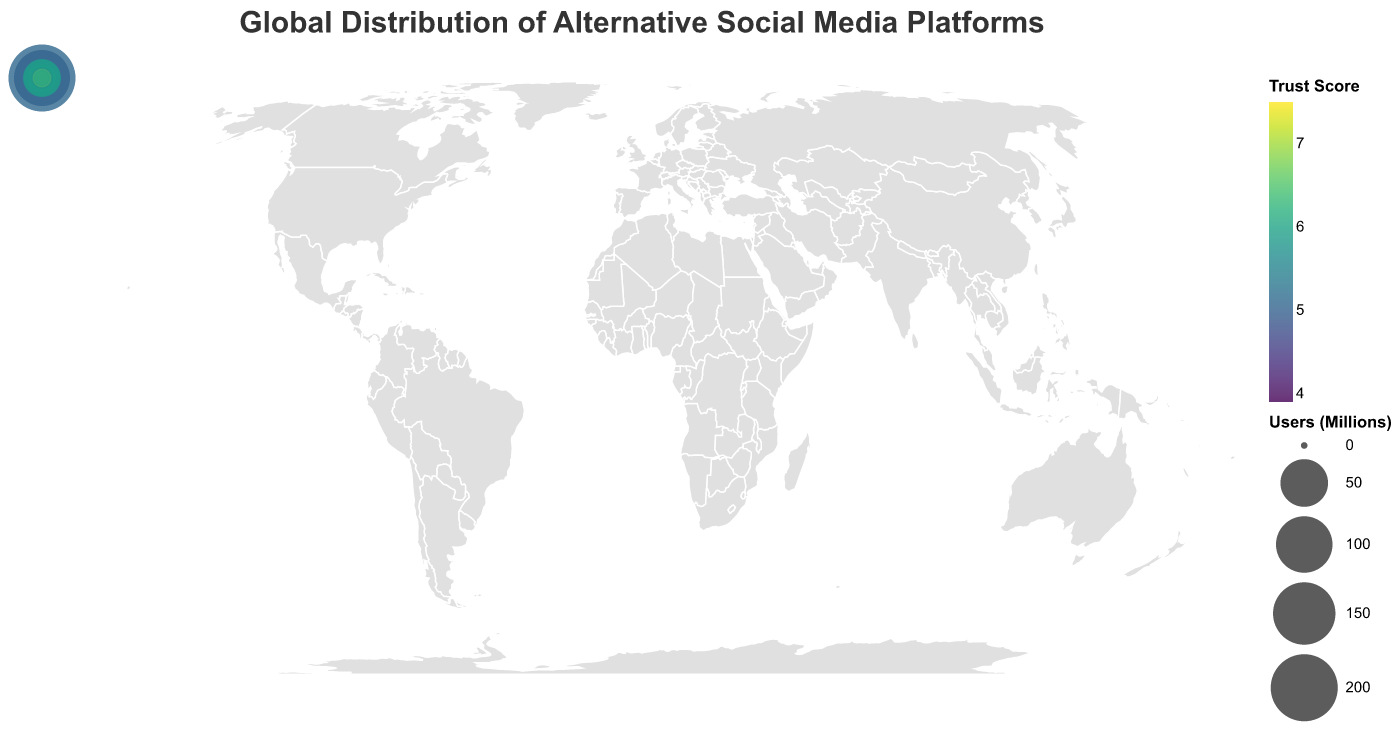What is the title of the figure? The title is written at the top of the figure. It reads "Global Distribution of Alternative Social Media Platforms"
Answer: Global Distribution of Alternative Social Media Platforms Which country has the highest number of users for its alternative social media platform, and what is the user count? By examining the sizes of the circles, we can see that China has the highest user count. The tooltip confirms this by displaying 200.0 million users for Douban in China.
Answer: China, 200 million What is the trust score of the platform with the highest number of users? The platform with the highest number of users is Douban in China. Looking at the tooltip, Douban has a trust score of 5.1.
Answer: 5.1 Which platform has the highest trust score, and in which country is it located? The tooltip data for Framasoft in France indicates a trust score of 7.5, which is the highest trust score among the platforms.
Answer: Framasoft, France How many countries have platforms with a trust score higher than 6.5? By hovering over and checking the tooltips of each country's platform, we find that the countries with trust scores higher than 6.5 include the United States (Mastodon, 7.2), Germany (Diaspora, 6.9), France (Framasoft, 7.5), Spain (Pleroma, 6.7), Netherlands (Movim, 6.4), and Sweden (Hubzilla, 6.8). Counting these gives us 6 countries.
Answer: 6 Which country has the lowest trust score for its alternative social media platform, and what is the trust score? The tooltip data for Gab in the United Kingdom shows a trust score of 3.9, which is the lowest.
Answer: United Kingdom, 3.9 Compare the user base of Mastodon in the United States and Koo in India. Which has more users, and by how much? Mastodon has 4.5 million users, and Koo has 20.0 million users. Subtracting 4.5 from 20.0 gives us 15.5 million.
Answer: Koo, by 15.5 million What is the average trust score of all the platforms? To find the average trust score, sum all the trust scores and divide by the number of data points. The trust scores are 7.2, 6.9, 6.5, 6.3, 4.8, 5.1, 5.7, 3.9, 4.2, 5.8, 7.5, 6.7, 6.4, 6.8, and 5.9. The sum is 93.7. There are 15 data points, so the average trust score is 93.7 / 15 = 6.25.
Answer: 6.25 Which platforms have both user bases over 5 million and trust scores over 6.0? Looking at the tooltips of each data point, Mastodon (USA, 4.5M, 7.2) and MeWe (Australia, 5.5M, 5.8) are candidates but MeWe matches the criteria for both. Therefore, MeWe has more than 5 million users but does not have a trust score over 6; only Mastodon in the USA would be left.
Answer: Mastodon (USA) What is the sum of all users across the platforms in countries with a trust score below 5.0? The platforms with a trust score below 5.0 are VK (Russia, 97M), Gab (UK, 1.5M), and Parler (Canada, 2.1M). Adding these user counts, we get 97 + 1.5 + 2.1 = 100.6 million users.
Answer: 100.6 million 